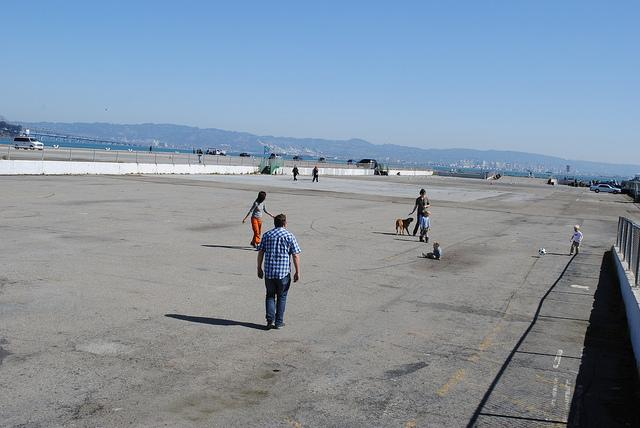What venue is it likely to be?

Choices:
A) football field
B) airfield
C) zoo
D) park airfield 